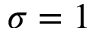Convert formula to latex. <formula><loc_0><loc_0><loc_500><loc_500>\sigma = 1</formula> 